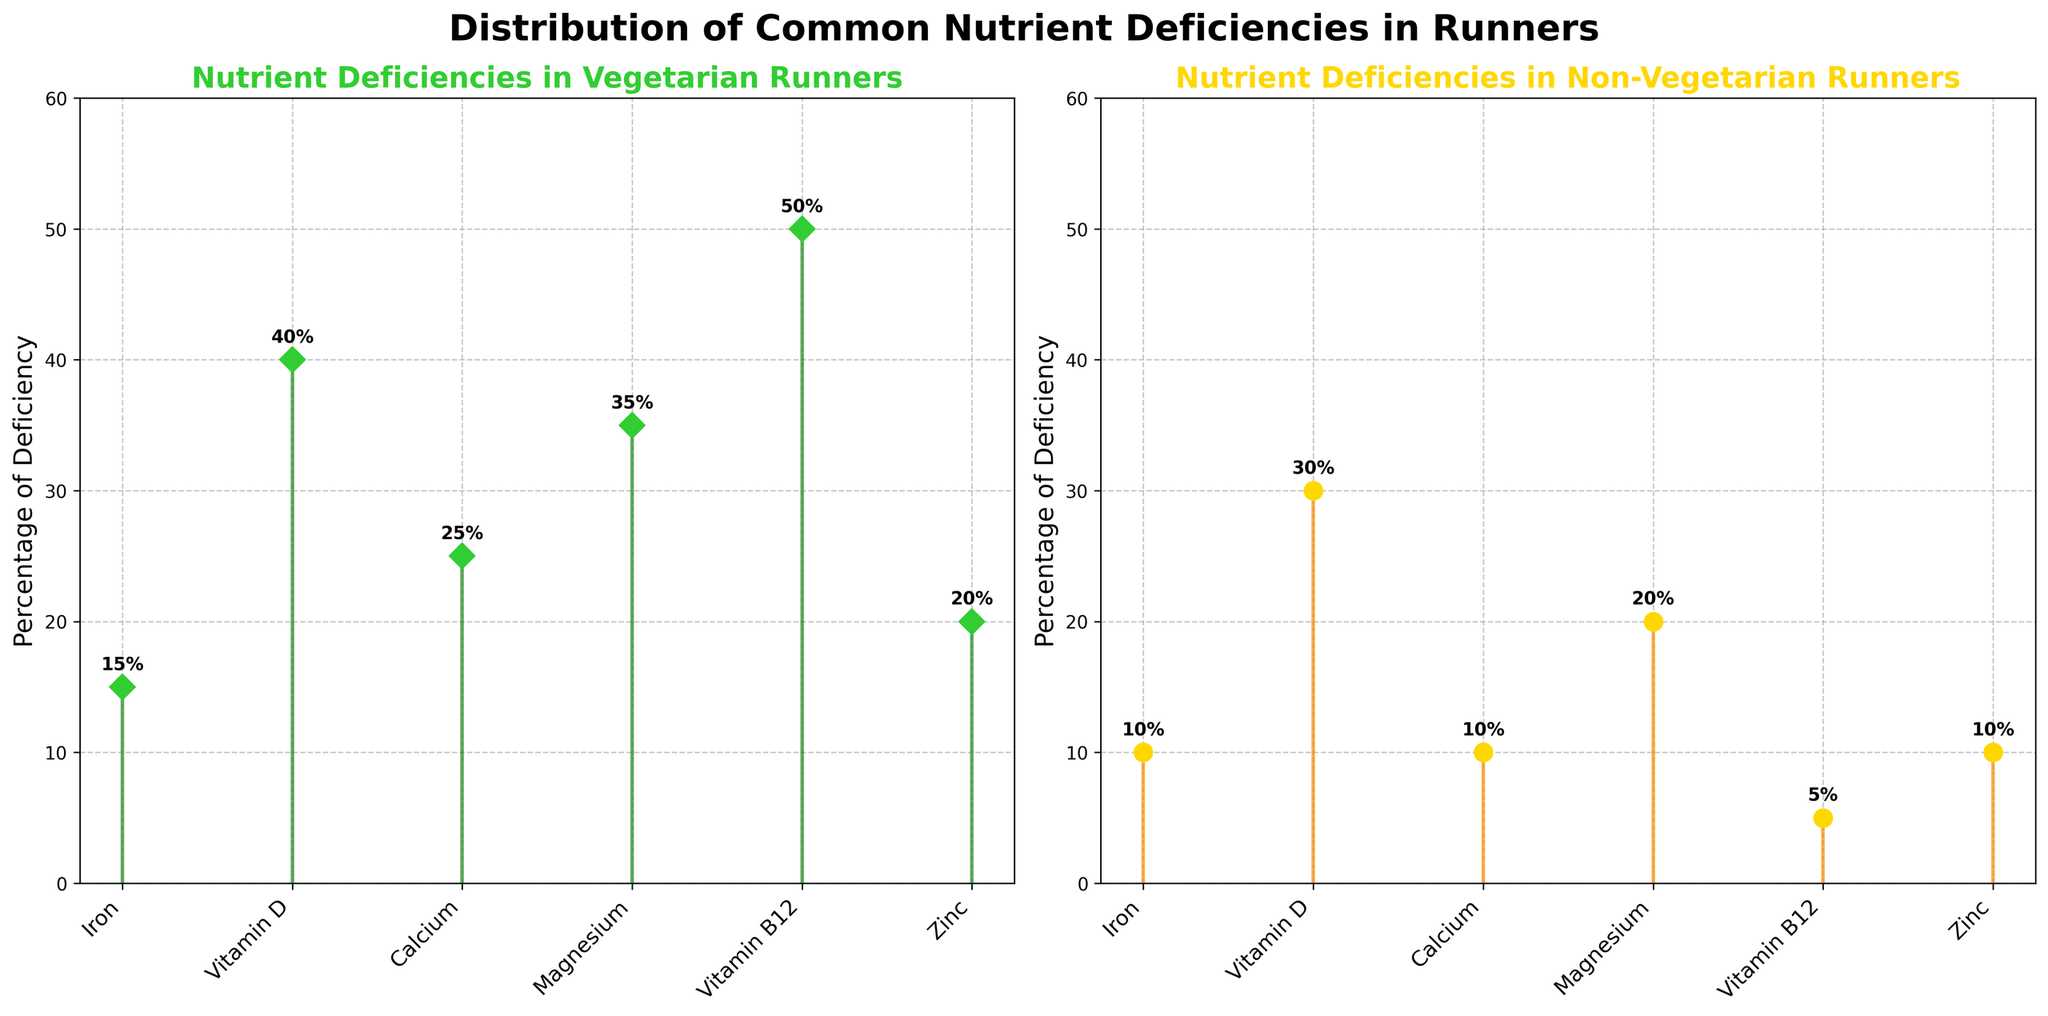What is the percentage of iron deficiency in vegetarian runners? The iron deficiency for vegetarian runners can be seen in the plot labeled 'Nutrient Deficiencies in Vegetarian Runners'. The value is represented by the height of the stem for iron.
Answer: 15% What nutrient has the highest deficiency in vegetarian runners? Looking at the plot for vegetarian runners, the nutrient with the highest stem reaching up to 50% is Vitamin B12.
Answer: Vitamin B12 Compare the percentage of magnesium deficiency between vegetarian and non-vegetarian runners. Which group has a higher deficiency? The plot shows magnesium deficiency at 35% for vegetarians and 20% for non-vegetarians. Since 35% is greater than 20%, vegetarians have a higher deficiency in magnesium.
Answer: Vegetarian runners How many nutrients have a higher deficiency in vegetarian runners compared to non-vegetarian runners? By comparing each stem of the nutrients between the two plots, vegetarians have higher deficiencies in Iron, Vitamin D, Calcium, Magnesium, Vitamin B12, and Zinc. That's a total of six nutrients.
Answer: 6 What is the percentage difference in Vitamin D deficiency between vegetarian and non-vegetarian runners? The Vitamin D deficiency is 40% for vegetarians and 30% for non-vegetarians. The difference is calculated as 40% - 30% = 10%.
Answer: 10% What is the title of the plot on the right-hand side? The title of the right plot, as seen above its frame, is 'Nutrient Deficiencies in Non-Vegetarian Runners'.
Answer: Nutrient Deficiencies in Non-Vegetarian Runners Which nutrient has the lowest deficiency in non-vegetarian runners? In the plot for non-vegetarian runners, the stem representing the lowest deficiency percentage is Vitamin B12 at 5%.
Answer: Vitamin B12 What nutrient has exactly a 10% deficiency in non-vegetarian runners and what is its deficiency in vegetarian runners? The non-vegetarian runner plot indicates that Iron and Calcium both have a 10% deficiency. In vegetarians, Iron is 15% and Calcium is 25%.
Answer: Iron: 15%, Calcium: 25% What is the average deficiency percentage of Zinc across both diet groups? Zinc deficiency is 20% for vegetarian runners and 10% for non-vegetarian runners. The average is calculated by (20% + 10%) / 2 = 15%.
Answer: 15% Is the deficiency percentage of Vitamin B12 in vegetarian runners more than double that of non-vegetarian runners? Vitamin B12 deficiency is 50% in vegetarians and 5% in non-vegetarians. Calculating double of 5%, we get 10%. Since 50% is more than 10%, the deficiency in vegetarians is indeed more than double.
Answer: Yes 